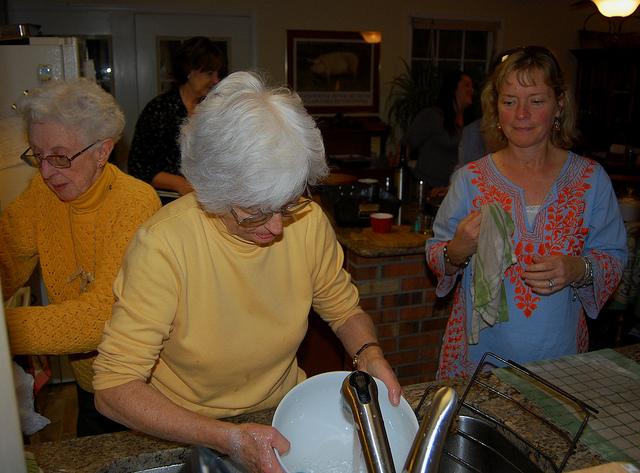Are any of the women wearing glasses?
Short answer required. Yes. What is she holding in her hands?
Short answer required. Bowl. What is the gender of the left most person?
Quick response, please. Woman. How many people are there?
Keep it brief. 6. How many are wearing glasses?
Answer briefly. 2. What is the woman holding in hand?
Write a very short answer. Bowl. What color is the photo?
Write a very short answer. Yellow. What color are the pants?
Write a very short answer. Blue. What are they doing?
Keep it brief. Washing dishes. Is there an exit sign?
Concise answer only. No. What type of shirt is she wearing?
Write a very short answer. Sweater. Is this in a classroom?
Concise answer only. No. Is a real person standing behind the woman?
Short answer required. Yes. What is in the oven?
Concise answer only. Pizza. Are they chefs?
Write a very short answer. No. Is the woman in blue thinking of helping with the dishes?
Write a very short answer. Yes. Is it outside?
Give a very brief answer. No. What is in front of the person with glasses?
Short answer required. Sink. 